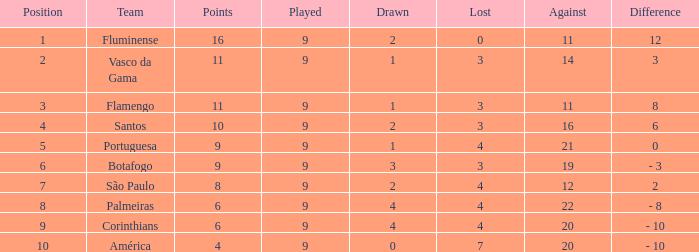Which Lost is the highest one that has a Drawn smaller than 4, and a Played smaller than 9? None. 